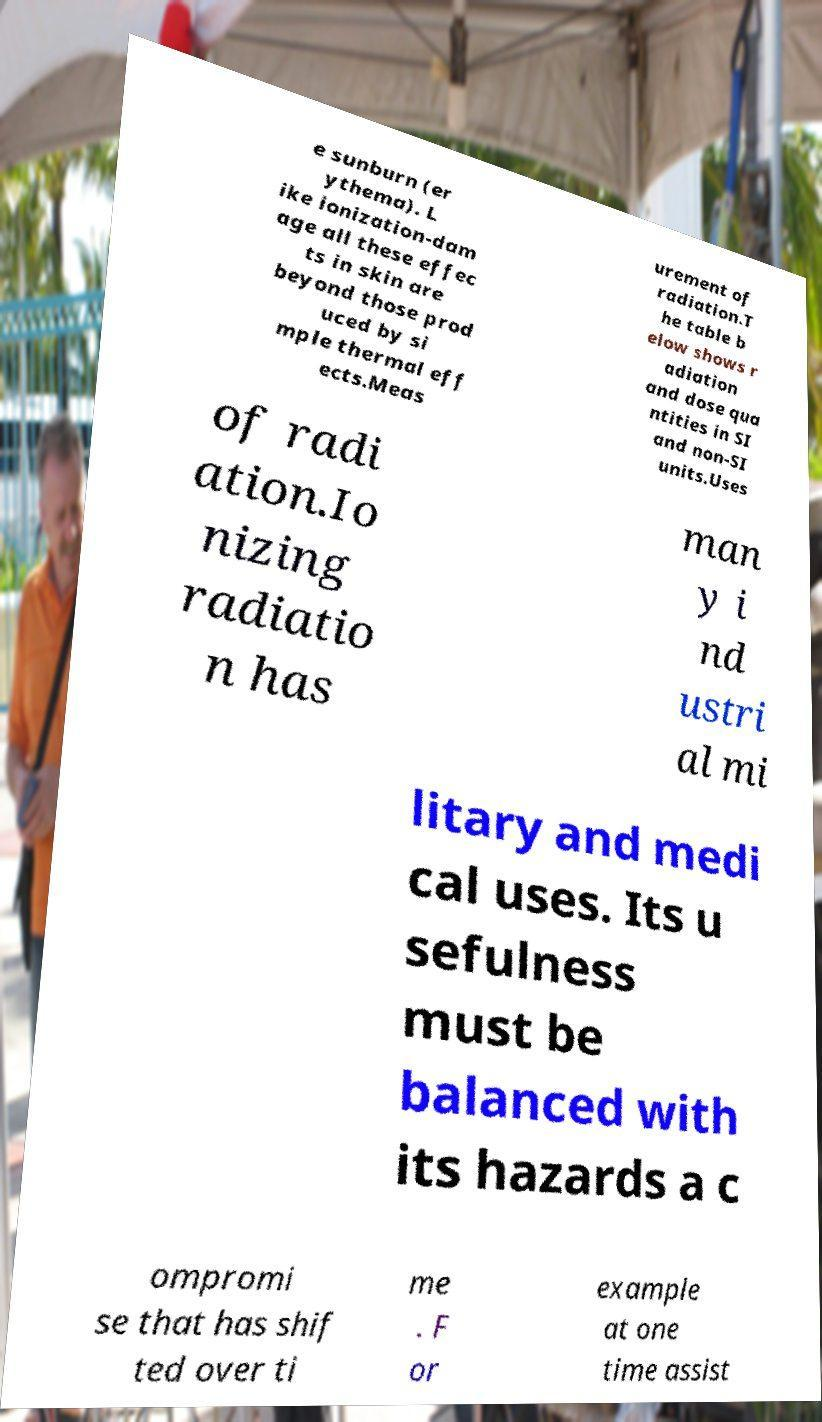Please read and relay the text visible in this image. What does it say? e sunburn (er ythema). L ike ionization-dam age all these effec ts in skin are beyond those prod uced by si mple thermal eff ects.Meas urement of radiation.T he table b elow shows r adiation and dose qua ntities in SI and non-SI units.Uses of radi ation.Io nizing radiatio n has man y i nd ustri al mi litary and medi cal uses. Its u sefulness must be balanced with its hazards a c ompromi se that has shif ted over ti me . F or example at one time assist 